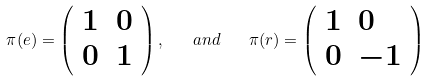<formula> <loc_0><loc_0><loc_500><loc_500>\pi ( e ) = \left ( \begin{array} { l l } 1 & 0 \\ 0 & 1 \end{array} \right ) , \quad a n d \quad \pi ( r ) = \left ( \begin{array} { l l } 1 & 0 \\ 0 & - 1 \end{array} \right )</formula> 